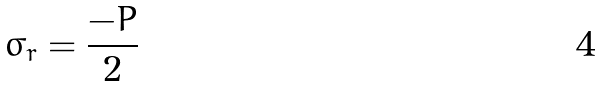<formula> <loc_0><loc_0><loc_500><loc_500>\sigma _ { r } = \frac { - P } { 2 }</formula> 